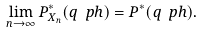<formula> <loc_0><loc_0><loc_500><loc_500>\lim _ { n \to \infty } P _ { X _ { n } } ^ { * } ( q \ p h ) = P ^ { * } ( q \ p h ) .</formula> 